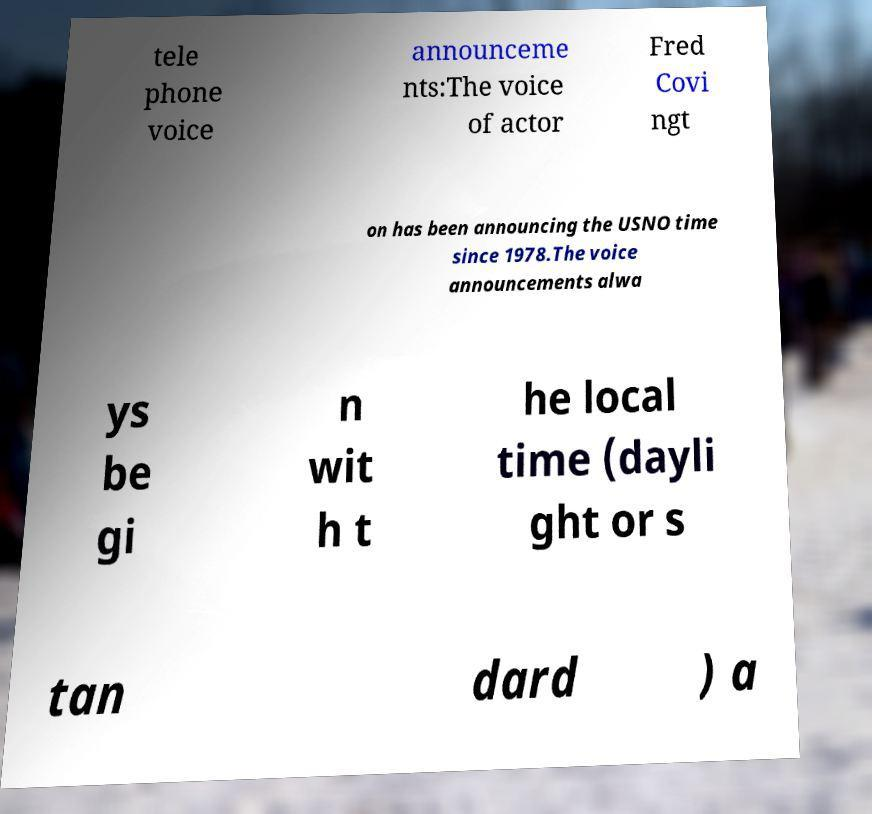Please read and relay the text visible in this image. What does it say? tele phone voice announceme nts:The voice of actor Fred Covi ngt on has been announcing the USNO time since 1978.The voice announcements alwa ys be gi n wit h t he local time (dayli ght or s tan dard ) a 